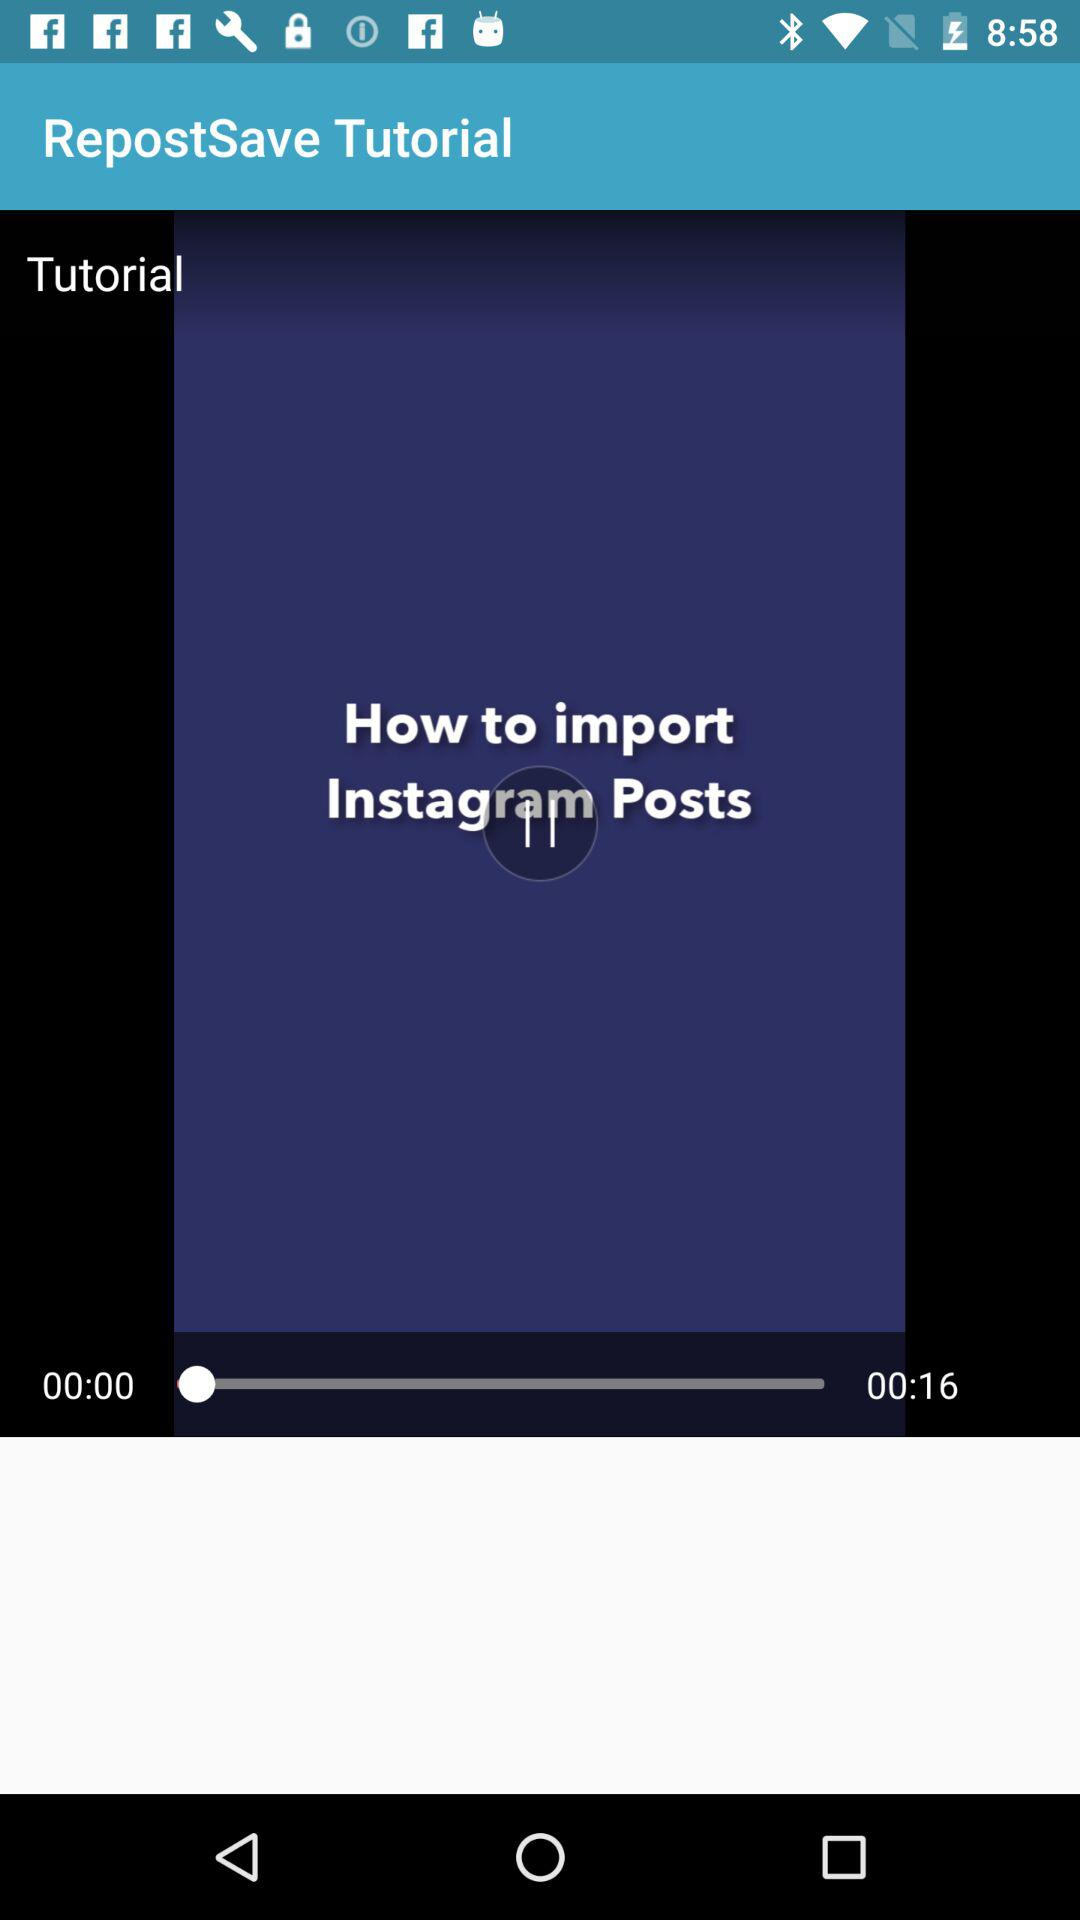What is the time duration? The time duration is 16 seconds. 